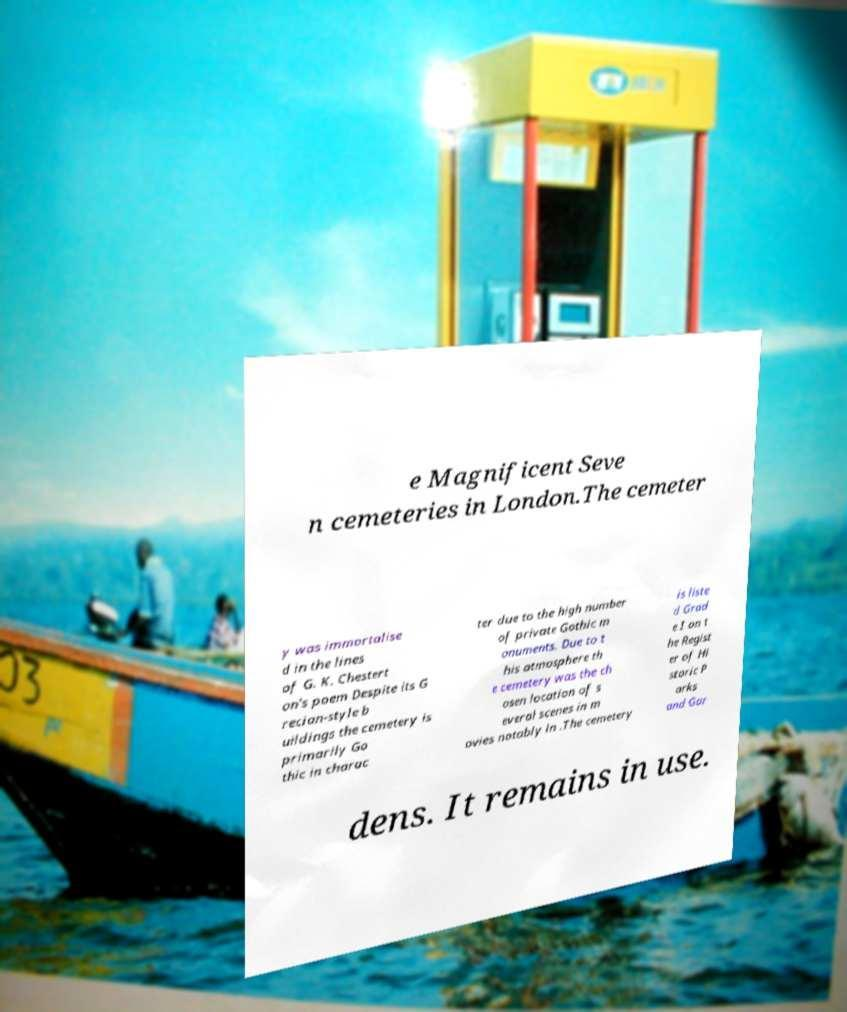Please read and relay the text visible in this image. What does it say? e Magnificent Seve n cemeteries in London.The cemeter y was immortalise d in the lines of G. K. Chestert on's poem Despite its G recian-style b uildings the cemetery is primarily Go thic in charac ter due to the high number of private Gothic m onuments. Due to t his atmosphere th e cemetery was the ch osen location of s everal scenes in m ovies notably in .The cemetery is liste d Grad e I on t he Regist er of Hi storic P arks and Gar dens. It remains in use. 